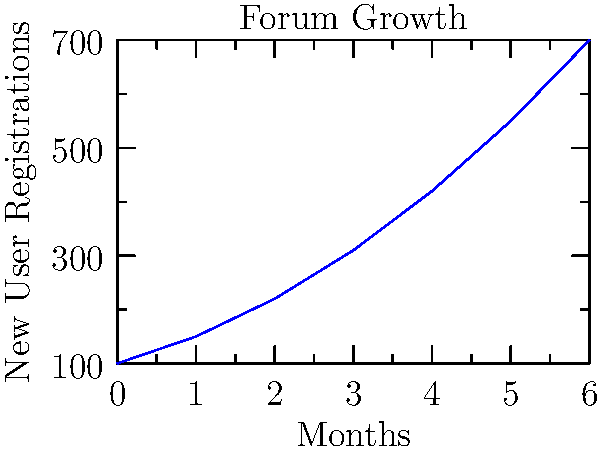As a forum administrator with a keen eye for detail, you're analyzing the growth of your community. The area chart shows new user registrations over a 6-month period. If the growth rate remains constant, approximately how many new users would you expect to register in the 9th month? To solve this problem, we need to follow these steps:

1. Analyze the growth pattern:
   The chart shows an exponential growth curve, not a linear one.

2. Calculate the growth rate:
   Let's use the last two data points to estimate the recent growth rate.
   Month 5: 550 users
   Month 6: 700 users
   Growth rate = $700 / 550 = 1.27$ (27% increase)

3. Project the growth:
   Month 7: $700 * 1.27 = 889$ (rounded)
   Month 8: $889 * 1.27 = 1129$ (rounded)
   Month 9: $1129 * 1.27 = 1434$ (rounded)

4. Verify the pattern:
   Check if this growth rate is consistent with earlier months:
   Month 4 to 5: $550 / 420 ≈ 1.31$
   Month 3 to 4: $420 / 310 ≈ 1.35$
   The rate is slightly decreasing, so our 1.27 estimate is conservative and reasonable.

5. Conclusion:
   Based on the current growth rate, we would expect approximately 1,434 new user registrations in the 9th month if the trend continues.
Answer: Approximately 1,434 new users 